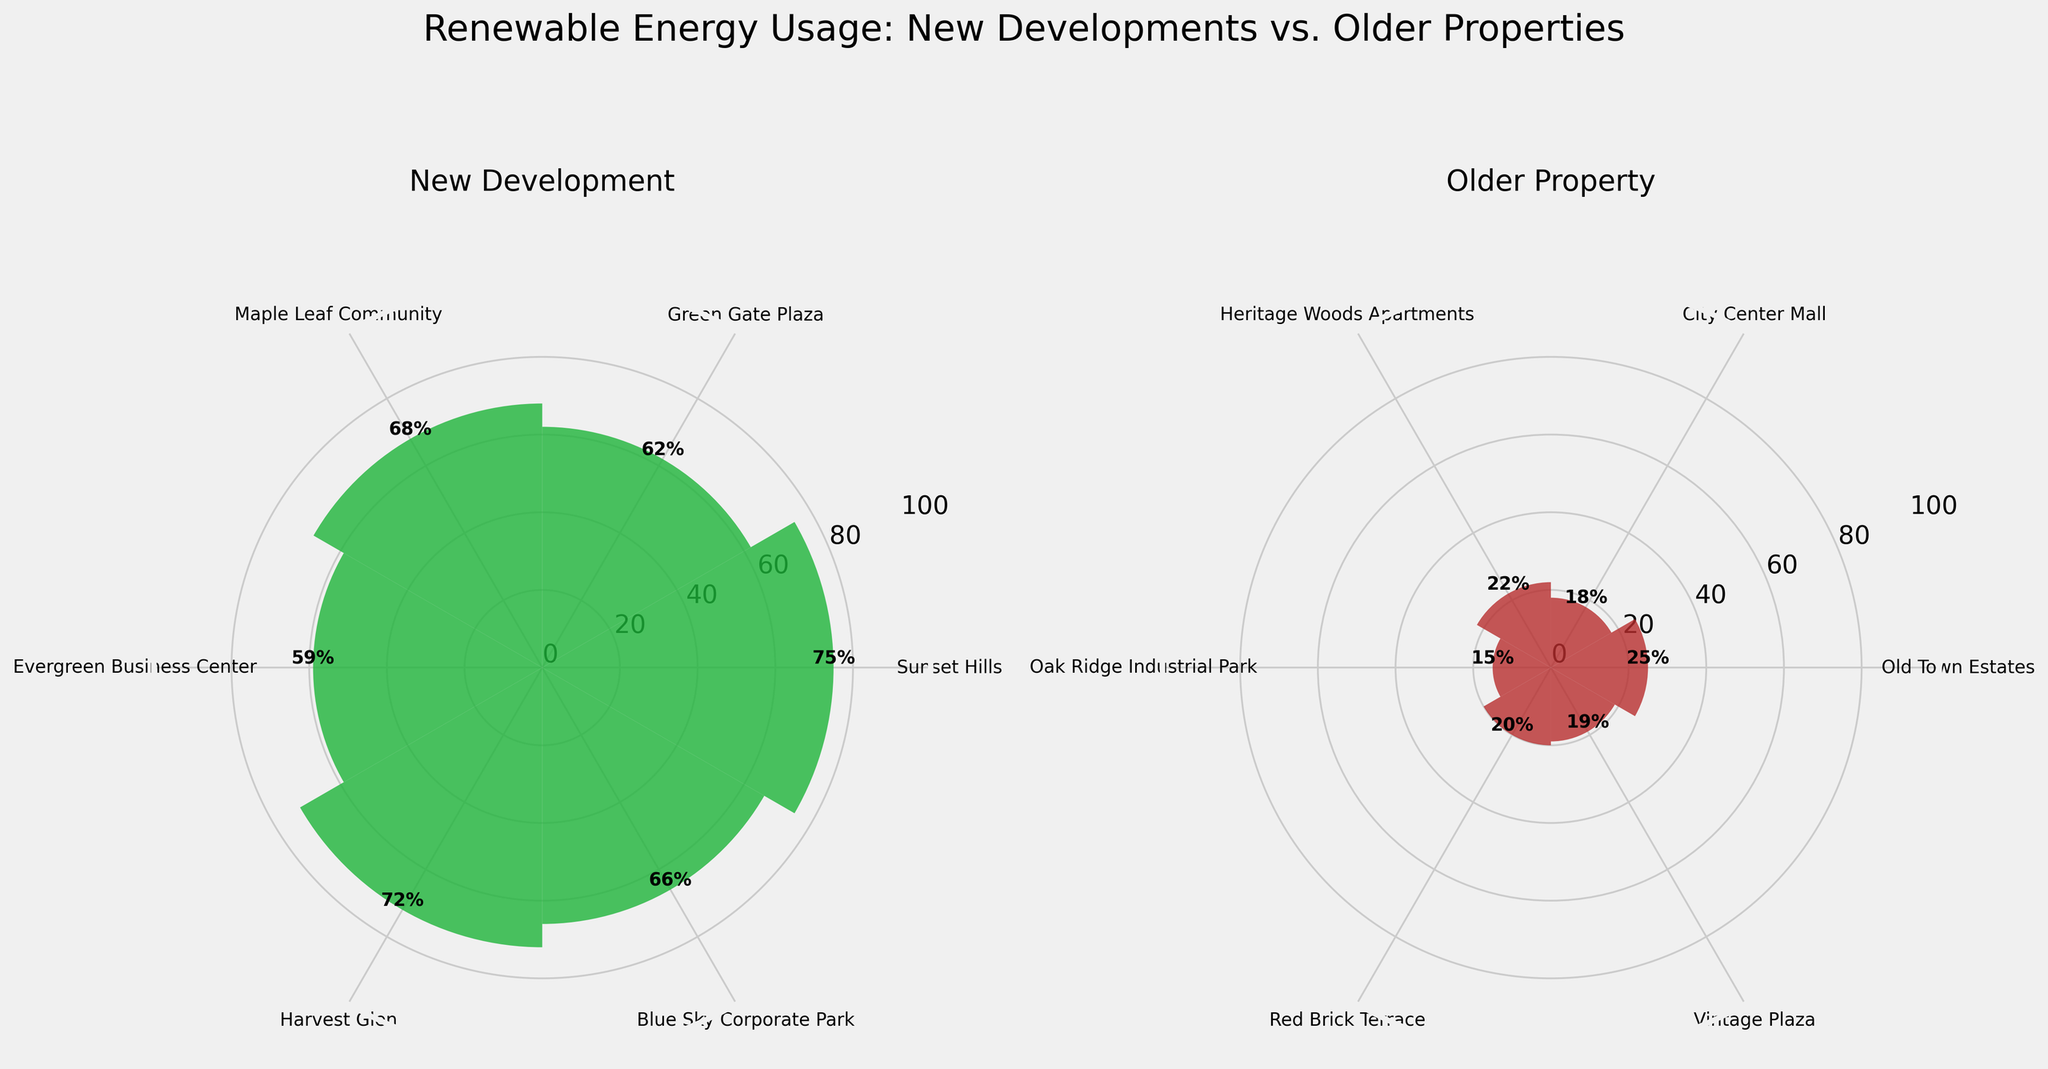What is the title of the figure? The figure title can be found at the top center of the plot. It reads "Renewable Energy Usage: New Developments vs. Older Properties."
Answer: Renewable Energy Usage: New Developments vs. Older Properties How many data points are there for new developments? We count the number of bars in the left polar subplot, which represents new developments. There are six bars.
Answer: 6 Which category has the higher average renewable energy usage? Calculate the average renewable energy usage by summing the values and dividing by the number of data points for each category. New Developments: (75 + 62 + 68 + 59 + 72 + 66) / 6 = 67. New Developments have an average of 67%, Older Properties: (25 + 18 + 22 + 15 + 20 + 19) / 6 = 19.83. Older Properties have an average of approximately 19.83%. Compare the two averages.
Answer: New Developments Which property has the highest renewable energy usage? Focus on the heights of the bars in both subplots and identify the tallest one. The tallest bar in the left subplot (New Developments) is Sunset Hills at 75%.
Answer: Sunset Hills What is the renewable energy usage percentage of the Blue Sky Corporate Park? Look at the label for Blue Sky Corporate Park in the left subplot (New Developments) and read off the height of the corresponding bar, which has a percentage label. It is 66%.
Answer: 66% How does the usage of renewable energy in City Center Mall compare to that in Heritage Woods Apartments? Locate the bars for City Center Mall (on the right plot, Older Properties) and Heritage Woods Apartments (on the right plot, Older Properties). City Center Mall has 18%, and Heritage Woods Apartments has 22%. Compare the two values.
Answer: City Center Mall has 4% less What is the combined renewable energy usage percentage for Maple Leaf Community and Harvest Glen? Add the renewable energy usage percentages for Maple Leaf Community (68%) and Harvest Glen (72%).
Answer: 140% Which new development commercial property has the highest renewable energy usage, and what is the percentage? Identify the commercial properties from the New Developments category (Green Gate Plaza, Evergreen Business Center, Blue Sky Corporate Park), and compare their percentages. Blue Sky Corporate Park has the highest at 66%.
Answer: Blue Sky Corporate Park, 66% Is there any development with exactly 25% renewable energy usage? Look for the bar with a height of 25% in the figure. Old Town Estates in the Older Properties category has this value.
Answer: Yes, Old Town Estates What is the difference in renewable energy usage between the highest in New Developments and highest in Older Properties? Identify the highest usage in New Developments (Sunset Hills at 75%) and in Older Properties (Old Town Estates at 25%). Subtract the latter from the former. 75% - 25% = 50%.
Answer: 50% 